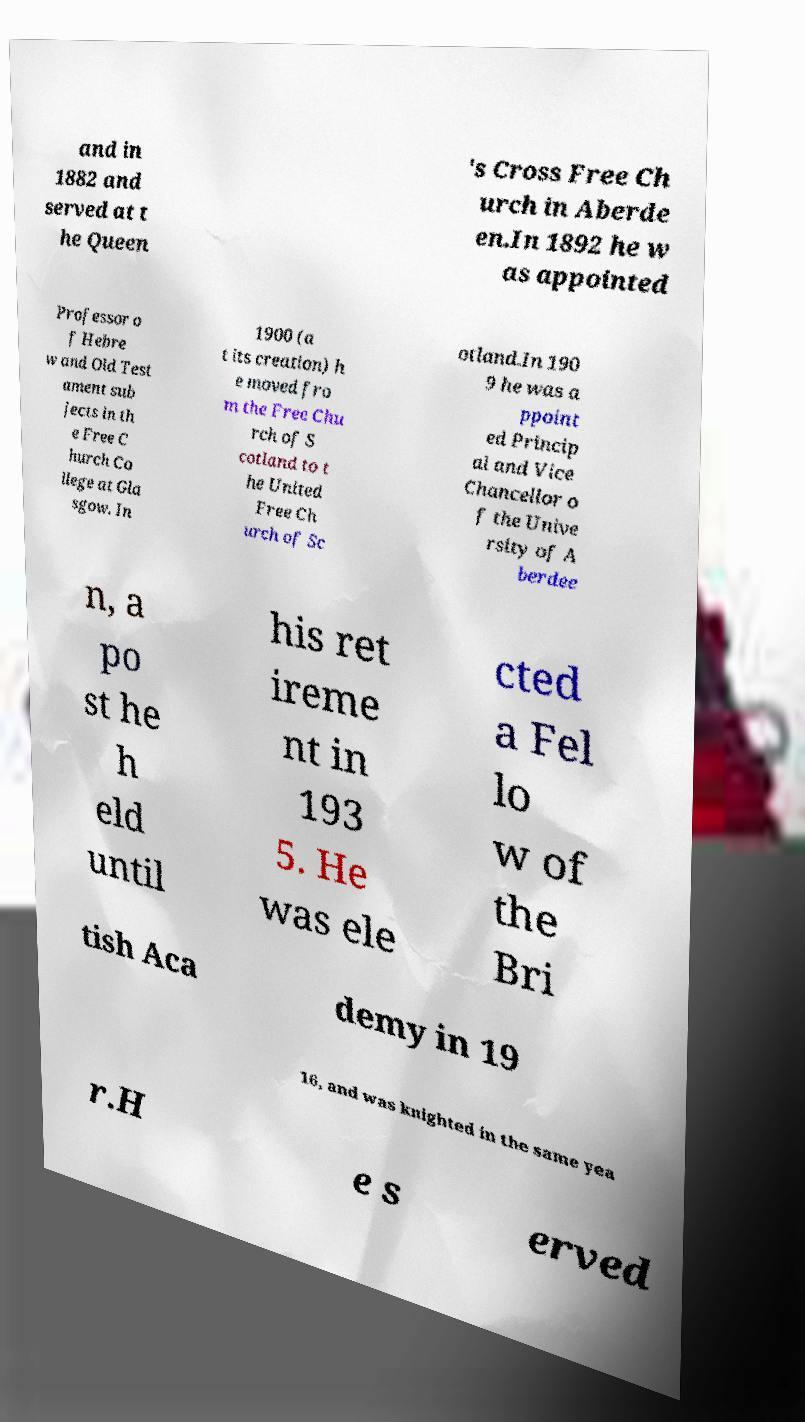Can you read and provide the text displayed in the image?This photo seems to have some interesting text. Can you extract and type it out for me? and in 1882 and served at t he Queen 's Cross Free Ch urch in Aberde en.In 1892 he w as appointed Professor o f Hebre w and Old Test ament sub jects in th e Free C hurch Co llege at Gla sgow. In 1900 (a t its creation) h e moved fro m the Free Chu rch of S cotland to t he United Free Ch urch of Sc otland.In 190 9 he was a ppoint ed Princip al and Vice Chancellor o f the Unive rsity of A berdee n, a po st he h eld until his ret ireme nt in 193 5. He was ele cted a Fel lo w of the Bri tish Aca demy in 19 16, and was knighted in the same yea r.H e s erved 